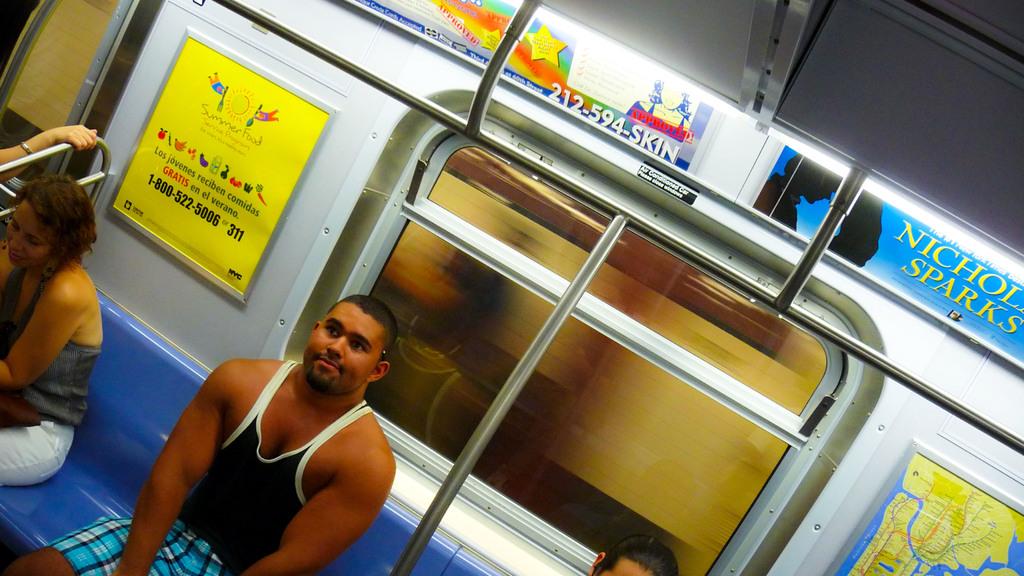What is advertised on the wall?
Offer a terse response. Nicholas sparks. Is he on a train?
Provide a succinct answer. Yes. 